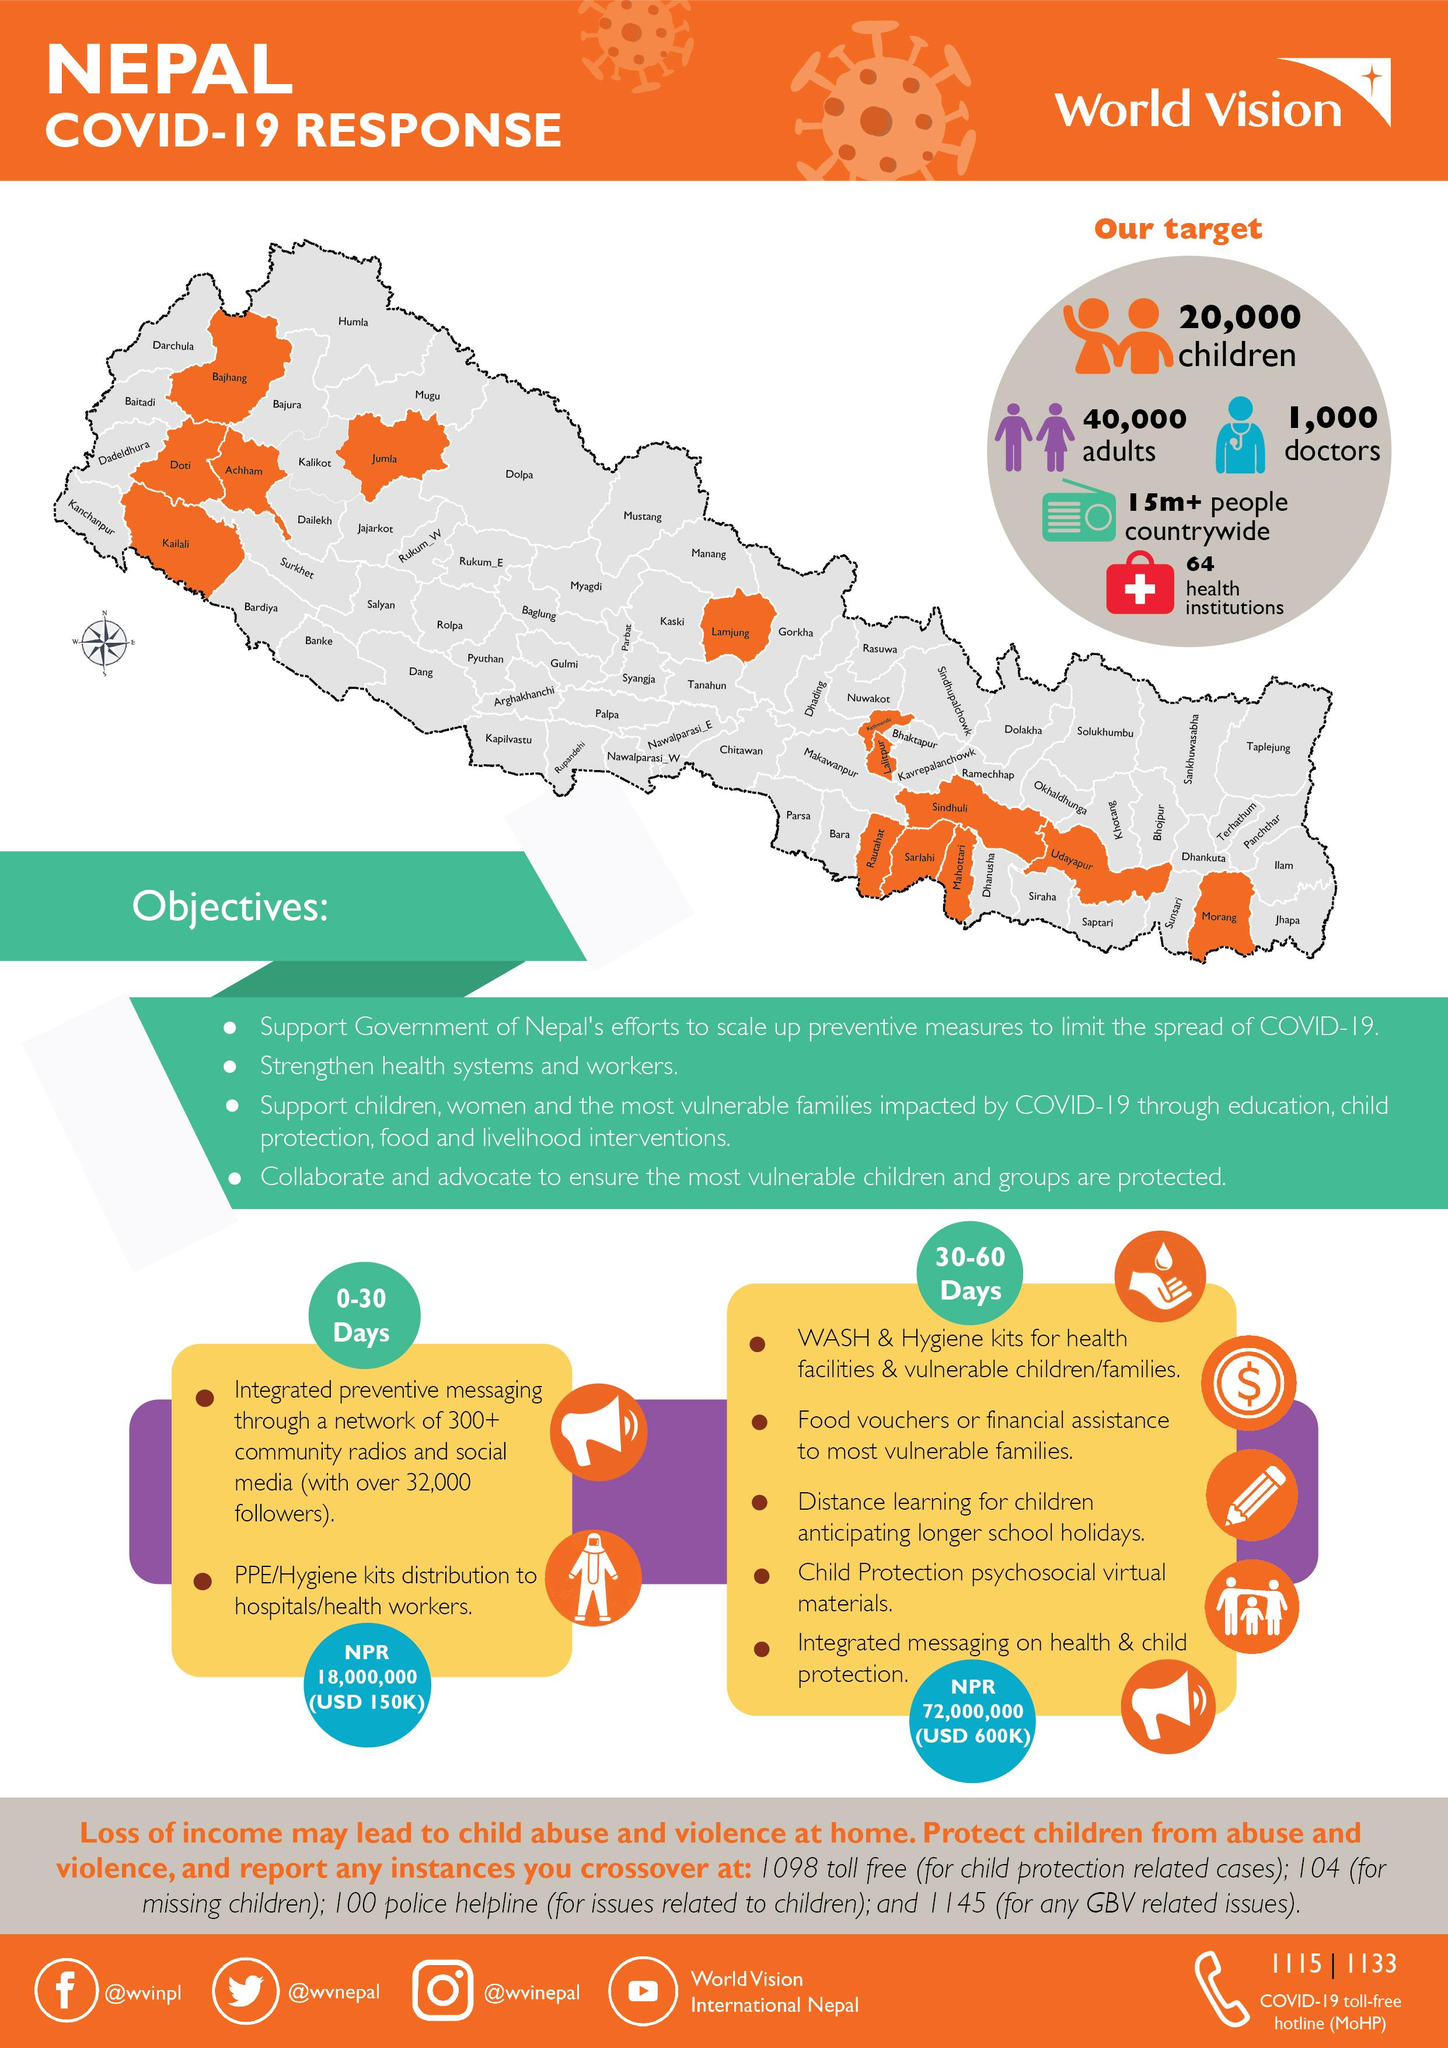Highlight a few significant elements in this photo. Given is the Instagram handle @wvinepal. Six telephone numbers are given. The YouTube channel mentioned is World Vision International Nepal. The Twitter handle "@wvnepal" has been provided. 